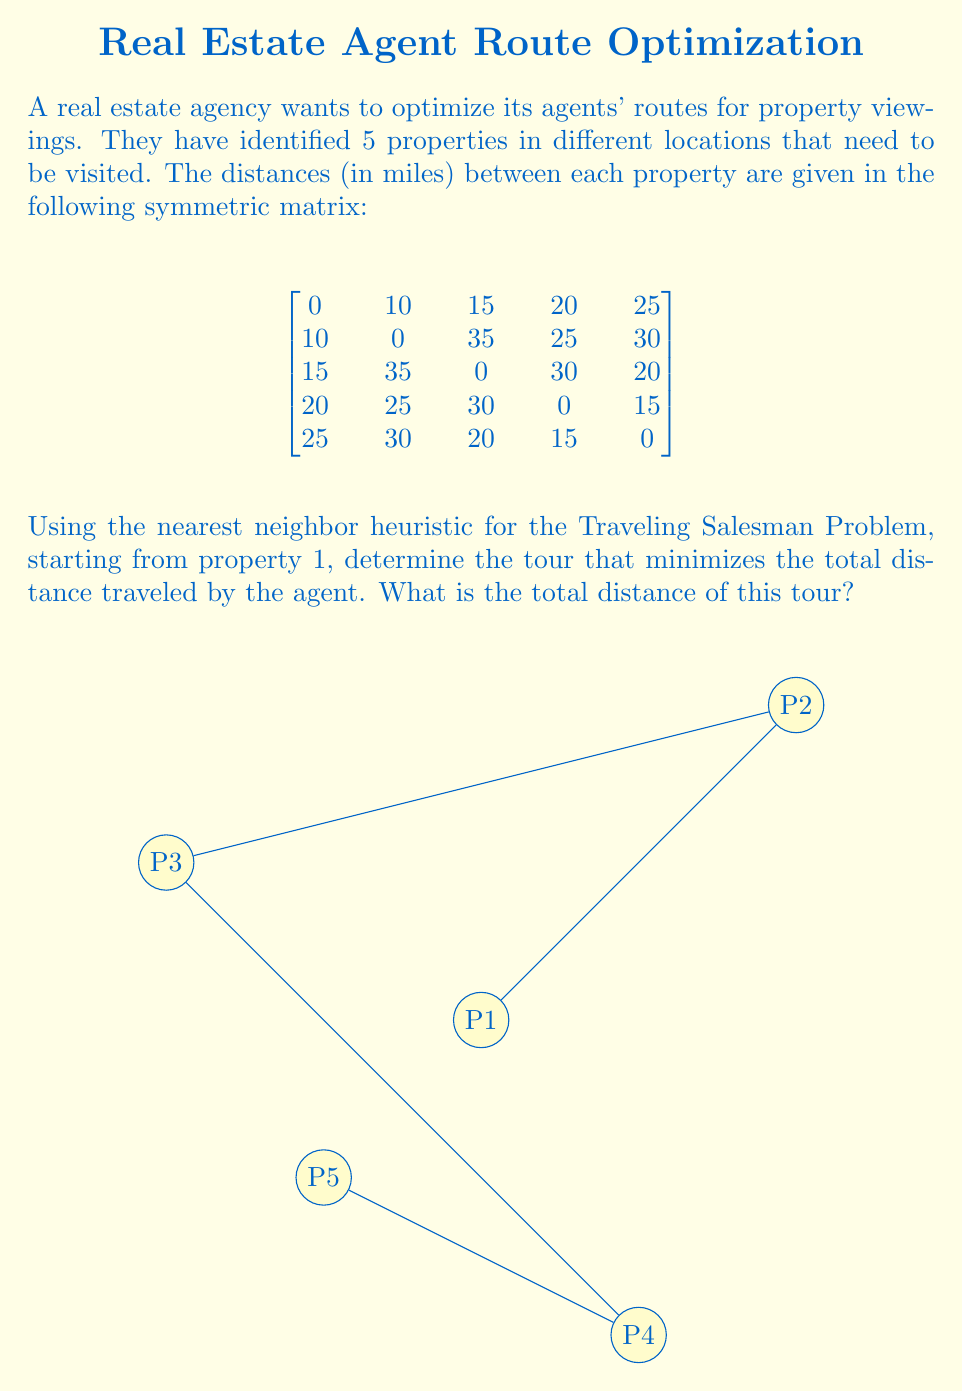Give your solution to this math problem. Let's solve this step-by-step using the nearest neighbor heuristic:

1) Start at property 1 (P1).

2) Find the nearest neighbor to P1:
   P2: 10 miles
   P3: 15 miles
   P4: 20 miles
   P5: 25 miles
   The nearest is P2 at 10 miles.

3) Move to P2 and find its nearest unvisited neighbor:
   P3: 35 miles
   P4: 25 miles
   P5: 30 miles
   The nearest is P4 at 25 miles.

4) Move to P4 and find its nearest unvisited neighbor:
   P3: 30 miles
   P5: 15 miles
   The nearest is P5 at 15 miles.

5) Move to P5 and visit the last remaining property, P3, at 20 miles.

6) Return to P1 from P3, which is 15 miles.

The tour is: P1 → P2 → P4 → P5 → P3 → P1

To calculate the total distance:
$$ \text{Total Distance} = 10 + 25 + 15 + 20 + 15 = 85 \text{ miles} $$
Answer: 85 miles 